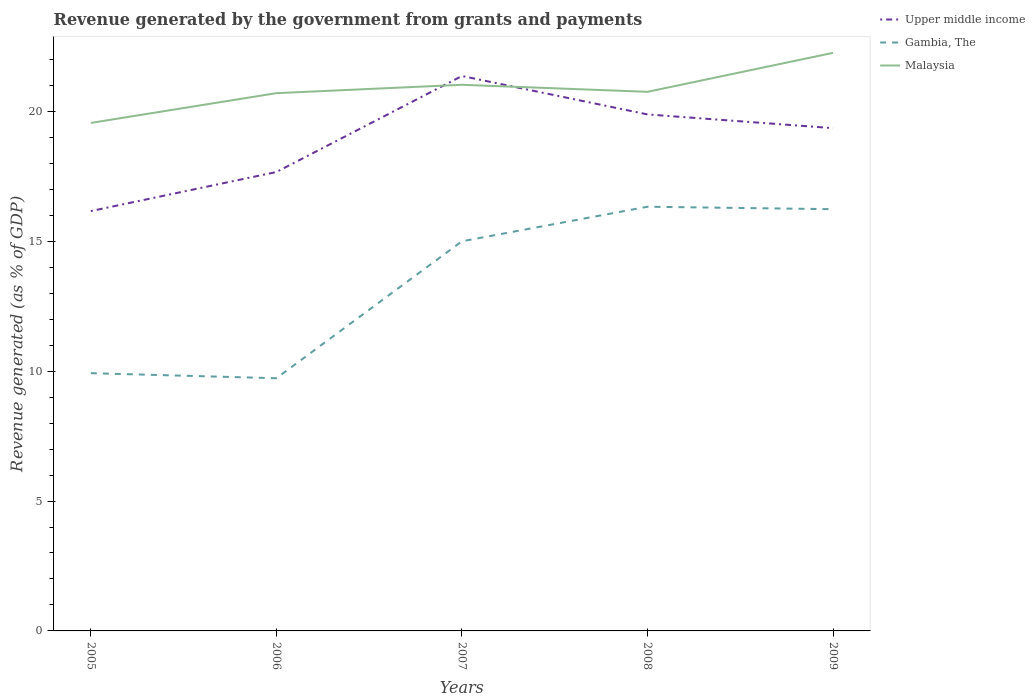Does the line corresponding to Gambia, The intersect with the line corresponding to Upper middle income?
Your response must be concise. No. Across all years, what is the maximum revenue generated by the government in Gambia, The?
Ensure brevity in your answer.  9.73. What is the total revenue generated by the government in Gambia, The in the graph?
Make the answer very short. -5.08. What is the difference between the highest and the second highest revenue generated by the government in Gambia, The?
Ensure brevity in your answer.  6.6. What is the difference between the highest and the lowest revenue generated by the government in Upper middle income?
Make the answer very short. 3. Is the revenue generated by the government in Malaysia strictly greater than the revenue generated by the government in Gambia, The over the years?
Keep it short and to the point. No. How many years are there in the graph?
Provide a short and direct response. 5. Does the graph contain any zero values?
Make the answer very short. No. Where does the legend appear in the graph?
Your answer should be very brief. Top right. How many legend labels are there?
Your answer should be very brief. 3. How are the legend labels stacked?
Make the answer very short. Vertical. What is the title of the graph?
Offer a very short reply. Revenue generated by the government from grants and payments. What is the label or title of the Y-axis?
Your response must be concise. Revenue generated (as % of GDP). What is the Revenue generated (as % of GDP) of Upper middle income in 2005?
Your answer should be compact. 16.16. What is the Revenue generated (as % of GDP) of Gambia, The in 2005?
Keep it short and to the point. 9.92. What is the Revenue generated (as % of GDP) in Malaysia in 2005?
Your response must be concise. 19.56. What is the Revenue generated (as % of GDP) of Upper middle income in 2006?
Give a very brief answer. 17.67. What is the Revenue generated (as % of GDP) of Gambia, The in 2006?
Offer a terse response. 9.73. What is the Revenue generated (as % of GDP) of Malaysia in 2006?
Your answer should be compact. 20.7. What is the Revenue generated (as % of GDP) of Upper middle income in 2007?
Your answer should be very brief. 21.36. What is the Revenue generated (as % of GDP) of Gambia, The in 2007?
Provide a short and direct response. 15. What is the Revenue generated (as % of GDP) of Malaysia in 2007?
Make the answer very short. 21.02. What is the Revenue generated (as % of GDP) in Upper middle income in 2008?
Your response must be concise. 19.88. What is the Revenue generated (as % of GDP) of Gambia, The in 2008?
Your answer should be very brief. 16.33. What is the Revenue generated (as % of GDP) in Malaysia in 2008?
Make the answer very short. 20.75. What is the Revenue generated (as % of GDP) in Upper middle income in 2009?
Your answer should be compact. 19.35. What is the Revenue generated (as % of GDP) of Gambia, The in 2009?
Keep it short and to the point. 16.23. What is the Revenue generated (as % of GDP) of Malaysia in 2009?
Offer a very short reply. 22.25. Across all years, what is the maximum Revenue generated (as % of GDP) in Upper middle income?
Provide a succinct answer. 21.36. Across all years, what is the maximum Revenue generated (as % of GDP) in Gambia, The?
Ensure brevity in your answer.  16.33. Across all years, what is the maximum Revenue generated (as % of GDP) in Malaysia?
Give a very brief answer. 22.25. Across all years, what is the minimum Revenue generated (as % of GDP) of Upper middle income?
Offer a terse response. 16.16. Across all years, what is the minimum Revenue generated (as % of GDP) in Gambia, The?
Ensure brevity in your answer.  9.73. Across all years, what is the minimum Revenue generated (as % of GDP) of Malaysia?
Offer a terse response. 19.56. What is the total Revenue generated (as % of GDP) in Upper middle income in the graph?
Offer a very short reply. 94.43. What is the total Revenue generated (as % of GDP) in Gambia, The in the graph?
Make the answer very short. 67.22. What is the total Revenue generated (as % of GDP) in Malaysia in the graph?
Your answer should be compact. 104.29. What is the difference between the Revenue generated (as % of GDP) in Upper middle income in 2005 and that in 2006?
Ensure brevity in your answer.  -1.5. What is the difference between the Revenue generated (as % of GDP) of Gambia, The in 2005 and that in 2006?
Offer a very short reply. 0.2. What is the difference between the Revenue generated (as % of GDP) in Malaysia in 2005 and that in 2006?
Offer a terse response. -1.15. What is the difference between the Revenue generated (as % of GDP) of Upper middle income in 2005 and that in 2007?
Give a very brief answer. -5.2. What is the difference between the Revenue generated (as % of GDP) of Gambia, The in 2005 and that in 2007?
Your response must be concise. -5.08. What is the difference between the Revenue generated (as % of GDP) in Malaysia in 2005 and that in 2007?
Ensure brevity in your answer.  -1.47. What is the difference between the Revenue generated (as % of GDP) of Upper middle income in 2005 and that in 2008?
Provide a succinct answer. -3.72. What is the difference between the Revenue generated (as % of GDP) of Gambia, The in 2005 and that in 2008?
Offer a terse response. -6.41. What is the difference between the Revenue generated (as % of GDP) in Malaysia in 2005 and that in 2008?
Your answer should be compact. -1.2. What is the difference between the Revenue generated (as % of GDP) of Upper middle income in 2005 and that in 2009?
Ensure brevity in your answer.  -3.19. What is the difference between the Revenue generated (as % of GDP) of Gambia, The in 2005 and that in 2009?
Offer a very short reply. -6.31. What is the difference between the Revenue generated (as % of GDP) of Malaysia in 2005 and that in 2009?
Provide a short and direct response. -2.7. What is the difference between the Revenue generated (as % of GDP) in Upper middle income in 2006 and that in 2007?
Provide a succinct answer. -3.7. What is the difference between the Revenue generated (as % of GDP) in Gambia, The in 2006 and that in 2007?
Give a very brief answer. -5.27. What is the difference between the Revenue generated (as % of GDP) in Malaysia in 2006 and that in 2007?
Your answer should be very brief. -0.32. What is the difference between the Revenue generated (as % of GDP) of Upper middle income in 2006 and that in 2008?
Provide a short and direct response. -2.22. What is the difference between the Revenue generated (as % of GDP) in Gambia, The in 2006 and that in 2008?
Your answer should be compact. -6.6. What is the difference between the Revenue generated (as % of GDP) of Malaysia in 2006 and that in 2008?
Offer a terse response. -0.05. What is the difference between the Revenue generated (as % of GDP) in Upper middle income in 2006 and that in 2009?
Ensure brevity in your answer.  -1.69. What is the difference between the Revenue generated (as % of GDP) of Gambia, The in 2006 and that in 2009?
Offer a very short reply. -6.51. What is the difference between the Revenue generated (as % of GDP) in Malaysia in 2006 and that in 2009?
Provide a short and direct response. -1.55. What is the difference between the Revenue generated (as % of GDP) of Upper middle income in 2007 and that in 2008?
Offer a very short reply. 1.48. What is the difference between the Revenue generated (as % of GDP) of Gambia, The in 2007 and that in 2008?
Offer a terse response. -1.33. What is the difference between the Revenue generated (as % of GDP) in Malaysia in 2007 and that in 2008?
Offer a very short reply. 0.27. What is the difference between the Revenue generated (as % of GDP) of Upper middle income in 2007 and that in 2009?
Offer a very short reply. 2.01. What is the difference between the Revenue generated (as % of GDP) of Gambia, The in 2007 and that in 2009?
Offer a very short reply. -1.23. What is the difference between the Revenue generated (as % of GDP) in Malaysia in 2007 and that in 2009?
Provide a short and direct response. -1.23. What is the difference between the Revenue generated (as % of GDP) in Upper middle income in 2008 and that in 2009?
Keep it short and to the point. 0.53. What is the difference between the Revenue generated (as % of GDP) in Gambia, The in 2008 and that in 2009?
Provide a succinct answer. 0.1. What is the difference between the Revenue generated (as % of GDP) of Malaysia in 2008 and that in 2009?
Offer a very short reply. -1.5. What is the difference between the Revenue generated (as % of GDP) of Upper middle income in 2005 and the Revenue generated (as % of GDP) of Gambia, The in 2006?
Give a very brief answer. 6.43. What is the difference between the Revenue generated (as % of GDP) in Upper middle income in 2005 and the Revenue generated (as % of GDP) in Malaysia in 2006?
Your answer should be compact. -4.54. What is the difference between the Revenue generated (as % of GDP) in Gambia, The in 2005 and the Revenue generated (as % of GDP) in Malaysia in 2006?
Offer a terse response. -10.78. What is the difference between the Revenue generated (as % of GDP) in Upper middle income in 2005 and the Revenue generated (as % of GDP) in Gambia, The in 2007?
Your answer should be compact. 1.16. What is the difference between the Revenue generated (as % of GDP) in Upper middle income in 2005 and the Revenue generated (as % of GDP) in Malaysia in 2007?
Make the answer very short. -4.86. What is the difference between the Revenue generated (as % of GDP) in Gambia, The in 2005 and the Revenue generated (as % of GDP) in Malaysia in 2007?
Your response must be concise. -11.1. What is the difference between the Revenue generated (as % of GDP) of Upper middle income in 2005 and the Revenue generated (as % of GDP) of Gambia, The in 2008?
Provide a short and direct response. -0.17. What is the difference between the Revenue generated (as % of GDP) in Upper middle income in 2005 and the Revenue generated (as % of GDP) in Malaysia in 2008?
Offer a very short reply. -4.59. What is the difference between the Revenue generated (as % of GDP) of Gambia, The in 2005 and the Revenue generated (as % of GDP) of Malaysia in 2008?
Offer a very short reply. -10.83. What is the difference between the Revenue generated (as % of GDP) of Upper middle income in 2005 and the Revenue generated (as % of GDP) of Gambia, The in 2009?
Make the answer very short. -0.07. What is the difference between the Revenue generated (as % of GDP) in Upper middle income in 2005 and the Revenue generated (as % of GDP) in Malaysia in 2009?
Provide a succinct answer. -6.09. What is the difference between the Revenue generated (as % of GDP) in Gambia, The in 2005 and the Revenue generated (as % of GDP) in Malaysia in 2009?
Offer a very short reply. -12.33. What is the difference between the Revenue generated (as % of GDP) of Upper middle income in 2006 and the Revenue generated (as % of GDP) of Gambia, The in 2007?
Ensure brevity in your answer.  2.67. What is the difference between the Revenue generated (as % of GDP) in Upper middle income in 2006 and the Revenue generated (as % of GDP) in Malaysia in 2007?
Your answer should be compact. -3.36. What is the difference between the Revenue generated (as % of GDP) of Gambia, The in 2006 and the Revenue generated (as % of GDP) of Malaysia in 2007?
Your response must be concise. -11.3. What is the difference between the Revenue generated (as % of GDP) in Upper middle income in 2006 and the Revenue generated (as % of GDP) in Gambia, The in 2008?
Ensure brevity in your answer.  1.34. What is the difference between the Revenue generated (as % of GDP) of Upper middle income in 2006 and the Revenue generated (as % of GDP) of Malaysia in 2008?
Make the answer very short. -3.09. What is the difference between the Revenue generated (as % of GDP) in Gambia, The in 2006 and the Revenue generated (as % of GDP) in Malaysia in 2008?
Ensure brevity in your answer.  -11.03. What is the difference between the Revenue generated (as % of GDP) of Upper middle income in 2006 and the Revenue generated (as % of GDP) of Gambia, The in 2009?
Keep it short and to the point. 1.43. What is the difference between the Revenue generated (as % of GDP) in Upper middle income in 2006 and the Revenue generated (as % of GDP) in Malaysia in 2009?
Offer a very short reply. -4.59. What is the difference between the Revenue generated (as % of GDP) in Gambia, The in 2006 and the Revenue generated (as % of GDP) in Malaysia in 2009?
Give a very brief answer. -12.53. What is the difference between the Revenue generated (as % of GDP) in Upper middle income in 2007 and the Revenue generated (as % of GDP) in Gambia, The in 2008?
Offer a terse response. 5.03. What is the difference between the Revenue generated (as % of GDP) of Upper middle income in 2007 and the Revenue generated (as % of GDP) of Malaysia in 2008?
Ensure brevity in your answer.  0.61. What is the difference between the Revenue generated (as % of GDP) in Gambia, The in 2007 and the Revenue generated (as % of GDP) in Malaysia in 2008?
Your answer should be compact. -5.75. What is the difference between the Revenue generated (as % of GDP) in Upper middle income in 2007 and the Revenue generated (as % of GDP) in Gambia, The in 2009?
Provide a succinct answer. 5.13. What is the difference between the Revenue generated (as % of GDP) in Upper middle income in 2007 and the Revenue generated (as % of GDP) in Malaysia in 2009?
Your answer should be very brief. -0.89. What is the difference between the Revenue generated (as % of GDP) in Gambia, The in 2007 and the Revenue generated (as % of GDP) in Malaysia in 2009?
Provide a short and direct response. -7.25. What is the difference between the Revenue generated (as % of GDP) in Upper middle income in 2008 and the Revenue generated (as % of GDP) in Gambia, The in 2009?
Give a very brief answer. 3.65. What is the difference between the Revenue generated (as % of GDP) in Upper middle income in 2008 and the Revenue generated (as % of GDP) in Malaysia in 2009?
Give a very brief answer. -2.37. What is the difference between the Revenue generated (as % of GDP) of Gambia, The in 2008 and the Revenue generated (as % of GDP) of Malaysia in 2009?
Provide a short and direct response. -5.92. What is the average Revenue generated (as % of GDP) in Upper middle income per year?
Your answer should be compact. 18.89. What is the average Revenue generated (as % of GDP) in Gambia, The per year?
Your answer should be compact. 13.44. What is the average Revenue generated (as % of GDP) in Malaysia per year?
Your answer should be compact. 20.86. In the year 2005, what is the difference between the Revenue generated (as % of GDP) of Upper middle income and Revenue generated (as % of GDP) of Gambia, The?
Your answer should be compact. 6.24. In the year 2005, what is the difference between the Revenue generated (as % of GDP) in Upper middle income and Revenue generated (as % of GDP) in Malaysia?
Make the answer very short. -3.39. In the year 2005, what is the difference between the Revenue generated (as % of GDP) of Gambia, The and Revenue generated (as % of GDP) of Malaysia?
Make the answer very short. -9.63. In the year 2006, what is the difference between the Revenue generated (as % of GDP) in Upper middle income and Revenue generated (as % of GDP) in Gambia, The?
Make the answer very short. 7.94. In the year 2006, what is the difference between the Revenue generated (as % of GDP) in Upper middle income and Revenue generated (as % of GDP) in Malaysia?
Offer a very short reply. -3.04. In the year 2006, what is the difference between the Revenue generated (as % of GDP) in Gambia, The and Revenue generated (as % of GDP) in Malaysia?
Ensure brevity in your answer.  -10.97. In the year 2007, what is the difference between the Revenue generated (as % of GDP) of Upper middle income and Revenue generated (as % of GDP) of Gambia, The?
Your answer should be compact. 6.36. In the year 2007, what is the difference between the Revenue generated (as % of GDP) in Upper middle income and Revenue generated (as % of GDP) in Malaysia?
Give a very brief answer. 0.34. In the year 2007, what is the difference between the Revenue generated (as % of GDP) in Gambia, The and Revenue generated (as % of GDP) in Malaysia?
Provide a succinct answer. -6.02. In the year 2008, what is the difference between the Revenue generated (as % of GDP) in Upper middle income and Revenue generated (as % of GDP) in Gambia, The?
Make the answer very short. 3.55. In the year 2008, what is the difference between the Revenue generated (as % of GDP) in Upper middle income and Revenue generated (as % of GDP) in Malaysia?
Provide a succinct answer. -0.87. In the year 2008, what is the difference between the Revenue generated (as % of GDP) in Gambia, The and Revenue generated (as % of GDP) in Malaysia?
Give a very brief answer. -4.42. In the year 2009, what is the difference between the Revenue generated (as % of GDP) in Upper middle income and Revenue generated (as % of GDP) in Gambia, The?
Provide a succinct answer. 3.12. In the year 2009, what is the difference between the Revenue generated (as % of GDP) in Upper middle income and Revenue generated (as % of GDP) in Malaysia?
Ensure brevity in your answer.  -2.9. In the year 2009, what is the difference between the Revenue generated (as % of GDP) of Gambia, The and Revenue generated (as % of GDP) of Malaysia?
Your response must be concise. -6.02. What is the ratio of the Revenue generated (as % of GDP) in Upper middle income in 2005 to that in 2006?
Ensure brevity in your answer.  0.91. What is the ratio of the Revenue generated (as % of GDP) in Gambia, The in 2005 to that in 2006?
Make the answer very short. 1.02. What is the ratio of the Revenue generated (as % of GDP) in Malaysia in 2005 to that in 2006?
Make the answer very short. 0.94. What is the ratio of the Revenue generated (as % of GDP) in Upper middle income in 2005 to that in 2007?
Provide a short and direct response. 0.76. What is the ratio of the Revenue generated (as % of GDP) in Gambia, The in 2005 to that in 2007?
Provide a succinct answer. 0.66. What is the ratio of the Revenue generated (as % of GDP) in Malaysia in 2005 to that in 2007?
Make the answer very short. 0.93. What is the ratio of the Revenue generated (as % of GDP) of Upper middle income in 2005 to that in 2008?
Give a very brief answer. 0.81. What is the ratio of the Revenue generated (as % of GDP) of Gambia, The in 2005 to that in 2008?
Your answer should be compact. 0.61. What is the ratio of the Revenue generated (as % of GDP) in Malaysia in 2005 to that in 2008?
Your answer should be very brief. 0.94. What is the ratio of the Revenue generated (as % of GDP) of Upper middle income in 2005 to that in 2009?
Keep it short and to the point. 0.84. What is the ratio of the Revenue generated (as % of GDP) of Gambia, The in 2005 to that in 2009?
Keep it short and to the point. 0.61. What is the ratio of the Revenue generated (as % of GDP) in Malaysia in 2005 to that in 2009?
Keep it short and to the point. 0.88. What is the ratio of the Revenue generated (as % of GDP) in Upper middle income in 2006 to that in 2007?
Offer a terse response. 0.83. What is the ratio of the Revenue generated (as % of GDP) of Gambia, The in 2006 to that in 2007?
Ensure brevity in your answer.  0.65. What is the ratio of the Revenue generated (as % of GDP) in Malaysia in 2006 to that in 2007?
Provide a succinct answer. 0.98. What is the ratio of the Revenue generated (as % of GDP) of Upper middle income in 2006 to that in 2008?
Provide a short and direct response. 0.89. What is the ratio of the Revenue generated (as % of GDP) of Gambia, The in 2006 to that in 2008?
Make the answer very short. 0.6. What is the ratio of the Revenue generated (as % of GDP) of Malaysia in 2006 to that in 2008?
Offer a terse response. 1. What is the ratio of the Revenue generated (as % of GDP) of Upper middle income in 2006 to that in 2009?
Provide a succinct answer. 0.91. What is the ratio of the Revenue generated (as % of GDP) in Gambia, The in 2006 to that in 2009?
Your answer should be compact. 0.6. What is the ratio of the Revenue generated (as % of GDP) in Malaysia in 2006 to that in 2009?
Your response must be concise. 0.93. What is the ratio of the Revenue generated (as % of GDP) in Upper middle income in 2007 to that in 2008?
Ensure brevity in your answer.  1.07. What is the ratio of the Revenue generated (as % of GDP) in Gambia, The in 2007 to that in 2008?
Provide a succinct answer. 0.92. What is the ratio of the Revenue generated (as % of GDP) of Malaysia in 2007 to that in 2008?
Offer a very short reply. 1.01. What is the ratio of the Revenue generated (as % of GDP) of Upper middle income in 2007 to that in 2009?
Keep it short and to the point. 1.1. What is the ratio of the Revenue generated (as % of GDP) of Gambia, The in 2007 to that in 2009?
Provide a short and direct response. 0.92. What is the ratio of the Revenue generated (as % of GDP) in Malaysia in 2007 to that in 2009?
Provide a short and direct response. 0.94. What is the ratio of the Revenue generated (as % of GDP) of Upper middle income in 2008 to that in 2009?
Give a very brief answer. 1.03. What is the ratio of the Revenue generated (as % of GDP) of Gambia, The in 2008 to that in 2009?
Provide a succinct answer. 1.01. What is the ratio of the Revenue generated (as % of GDP) in Malaysia in 2008 to that in 2009?
Provide a short and direct response. 0.93. What is the difference between the highest and the second highest Revenue generated (as % of GDP) of Upper middle income?
Offer a terse response. 1.48. What is the difference between the highest and the second highest Revenue generated (as % of GDP) of Gambia, The?
Offer a terse response. 0.1. What is the difference between the highest and the second highest Revenue generated (as % of GDP) of Malaysia?
Your answer should be compact. 1.23. What is the difference between the highest and the lowest Revenue generated (as % of GDP) of Upper middle income?
Provide a short and direct response. 5.2. What is the difference between the highest and the lowest Revenue generated (as % of GDP) of Gambia, The?
Offer a very short reply. 6.6. What is the difference between the highest and the lowest Revenue generated (as % of GDP) of Malaysia?
Keep it short and to the point. 2.7. 